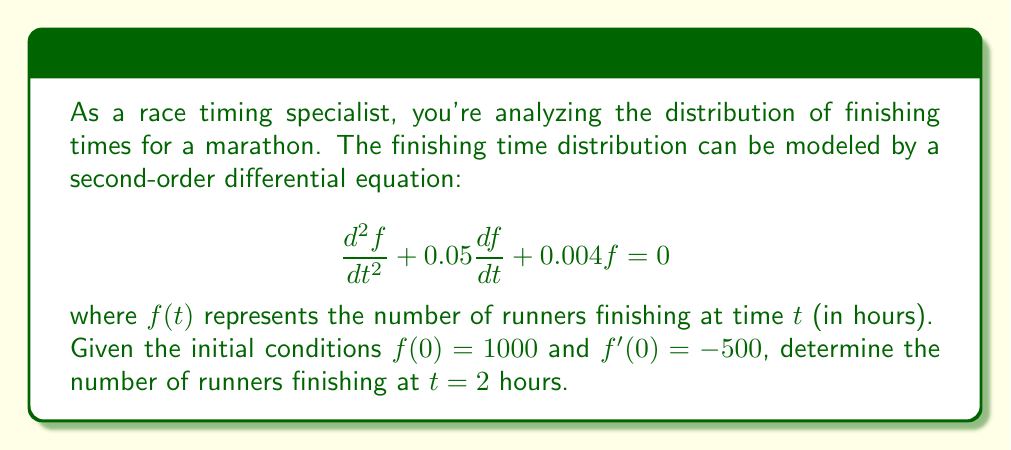Solve this math problem. To solve this problem, we'll follow these steps:

1) The characteristic equation for this second-order differential equation is:
   $$r^2 + 0.05r + 0.004 = 0$$

2) Solving this quadratic equation:
   $$r = \frac{-0.05 \pm \sqrt{0.05^2 - 4(0.004)}}{2} = -0.025 \pm 0.05i$$

3) The general solution is therefore:
   $$f(t) = e^{-0.025t}(A\cos(0.05t) + B\sin(0.05t))$$

4) Using the initial conditions:
   $f(0) = 1000$, so $A = 1000$
   $f'(0) = -500$, so $-0.025A + 0.05B = -500$
   
   Solving this: $B = -9500$

5) Thus, our particular solution is:
   $$f(t) = e^{-0.025t}(1000\cos(0.05t) - 9500\sin(0.05t))$$

6) To find $f(2)$, we substitute $t = 2$:
   $$f(2) = e^{-0.05}(1000\cos(0.1) - 9500\sin(0.1))$$

7) Calculating this:
   $$f(2) \approx 951.23 - 903.46 = 47.77$$
Answer: 48 runners (rounded to the nearest whole number) 